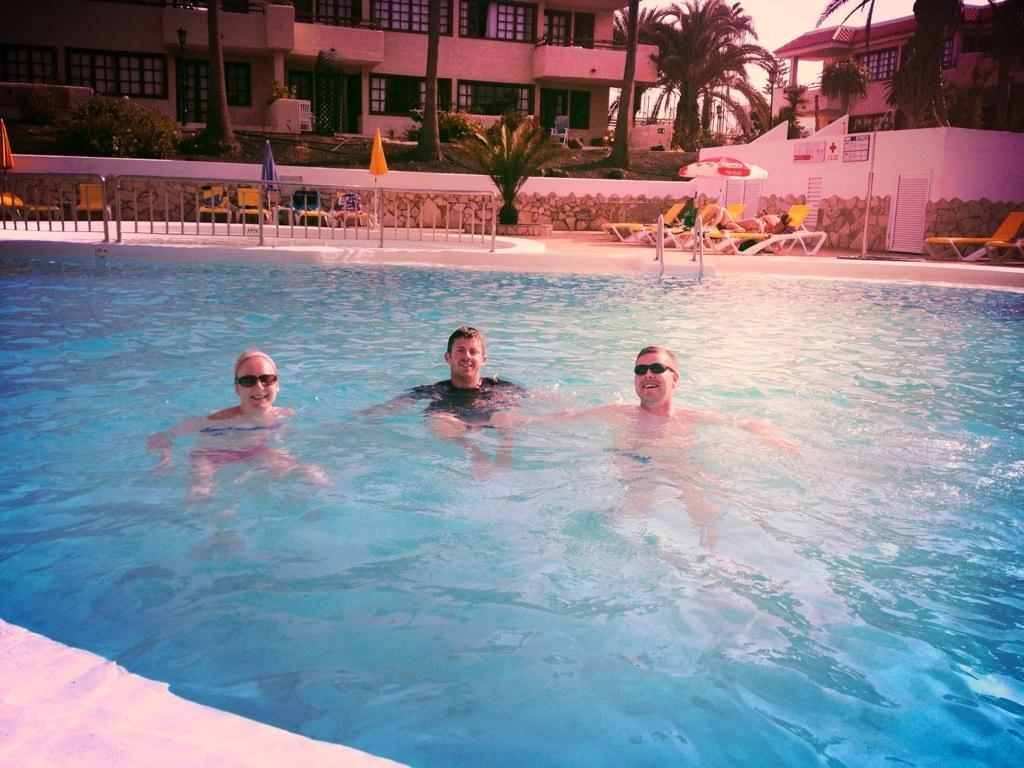How many people are in the water in the image? There are three people in the water in the image. What can be seen in the background of the image? There are trees, plants, chairs, buildings, and the sky visible in the background of the image. What type of honey is being collected by the people in the image? There is no honey or honey collection activity present in the image. 